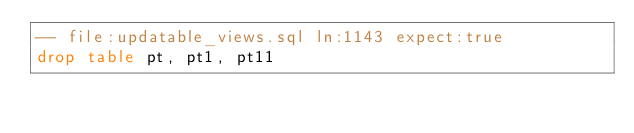Convert code to text. <code><loc_0><loc_0><loc_500><loc_500><_SQL_>-- file:updatable_views.sql ln:1143 expect:true
drop table pt, pt1, pt11
</code> 